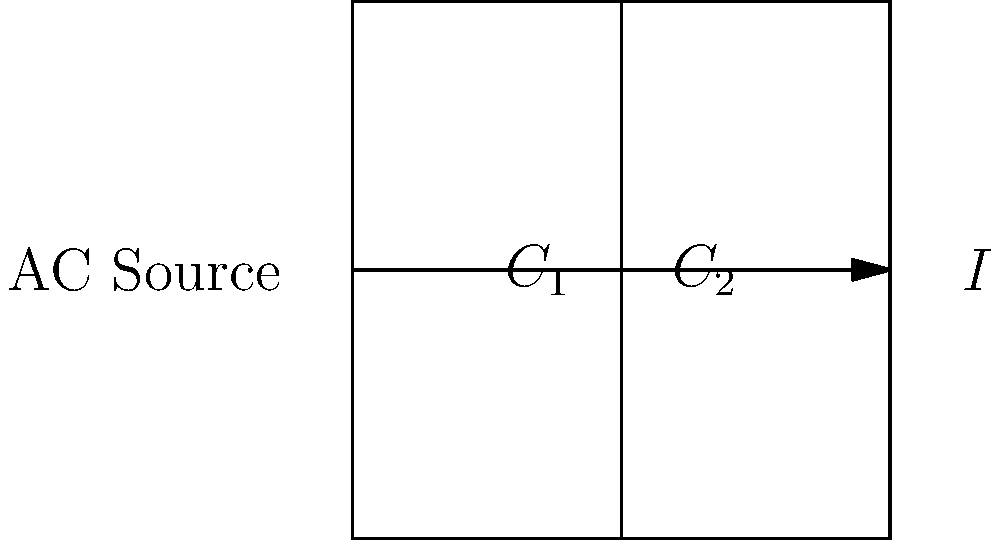In the parallel capacitor circuit shown above, if $C_1 = 10 \mu F$, $C_2 = 15 \mu F$, the AC source has a frequency of 60 Hz, and the applied voltage is 120 V RMS, what is the total current flowing through the circuit? To solve this problem, we'll follow these steps:

1) First, calculate the total capacitance ($C_T$) of the parallel circuit:
   $C_T = C_1 + C_2 = 10 \mu F + 15 \mu F = 25 \mu F$

2) Convert the capacitance to farads:
   $25 \mu F = 25 \times 10^{-6} F$

3) Calculate the angular frequency ($\omega$):
   $\omega = 2\pi f = 2\pi \times 60 = 377 \text{ rad/s}$

4) Calculate the capacitive reactance ($X_C$):
   $X_C = \frac{1}{\omega C} = \frac{1}{377 \times 25 \times 10^{-6}} = 106.1 \Omega$

5) Use Ohm's law to calculate the current:
   $I = \frac{V}{X_C} = \frac{120}{106.1} = 1.13 \text{ A RMS}$

Therefore, the total current flowing through the circuit is approximately 1.13 A RMS.
Answer: 1.13 A RMS 